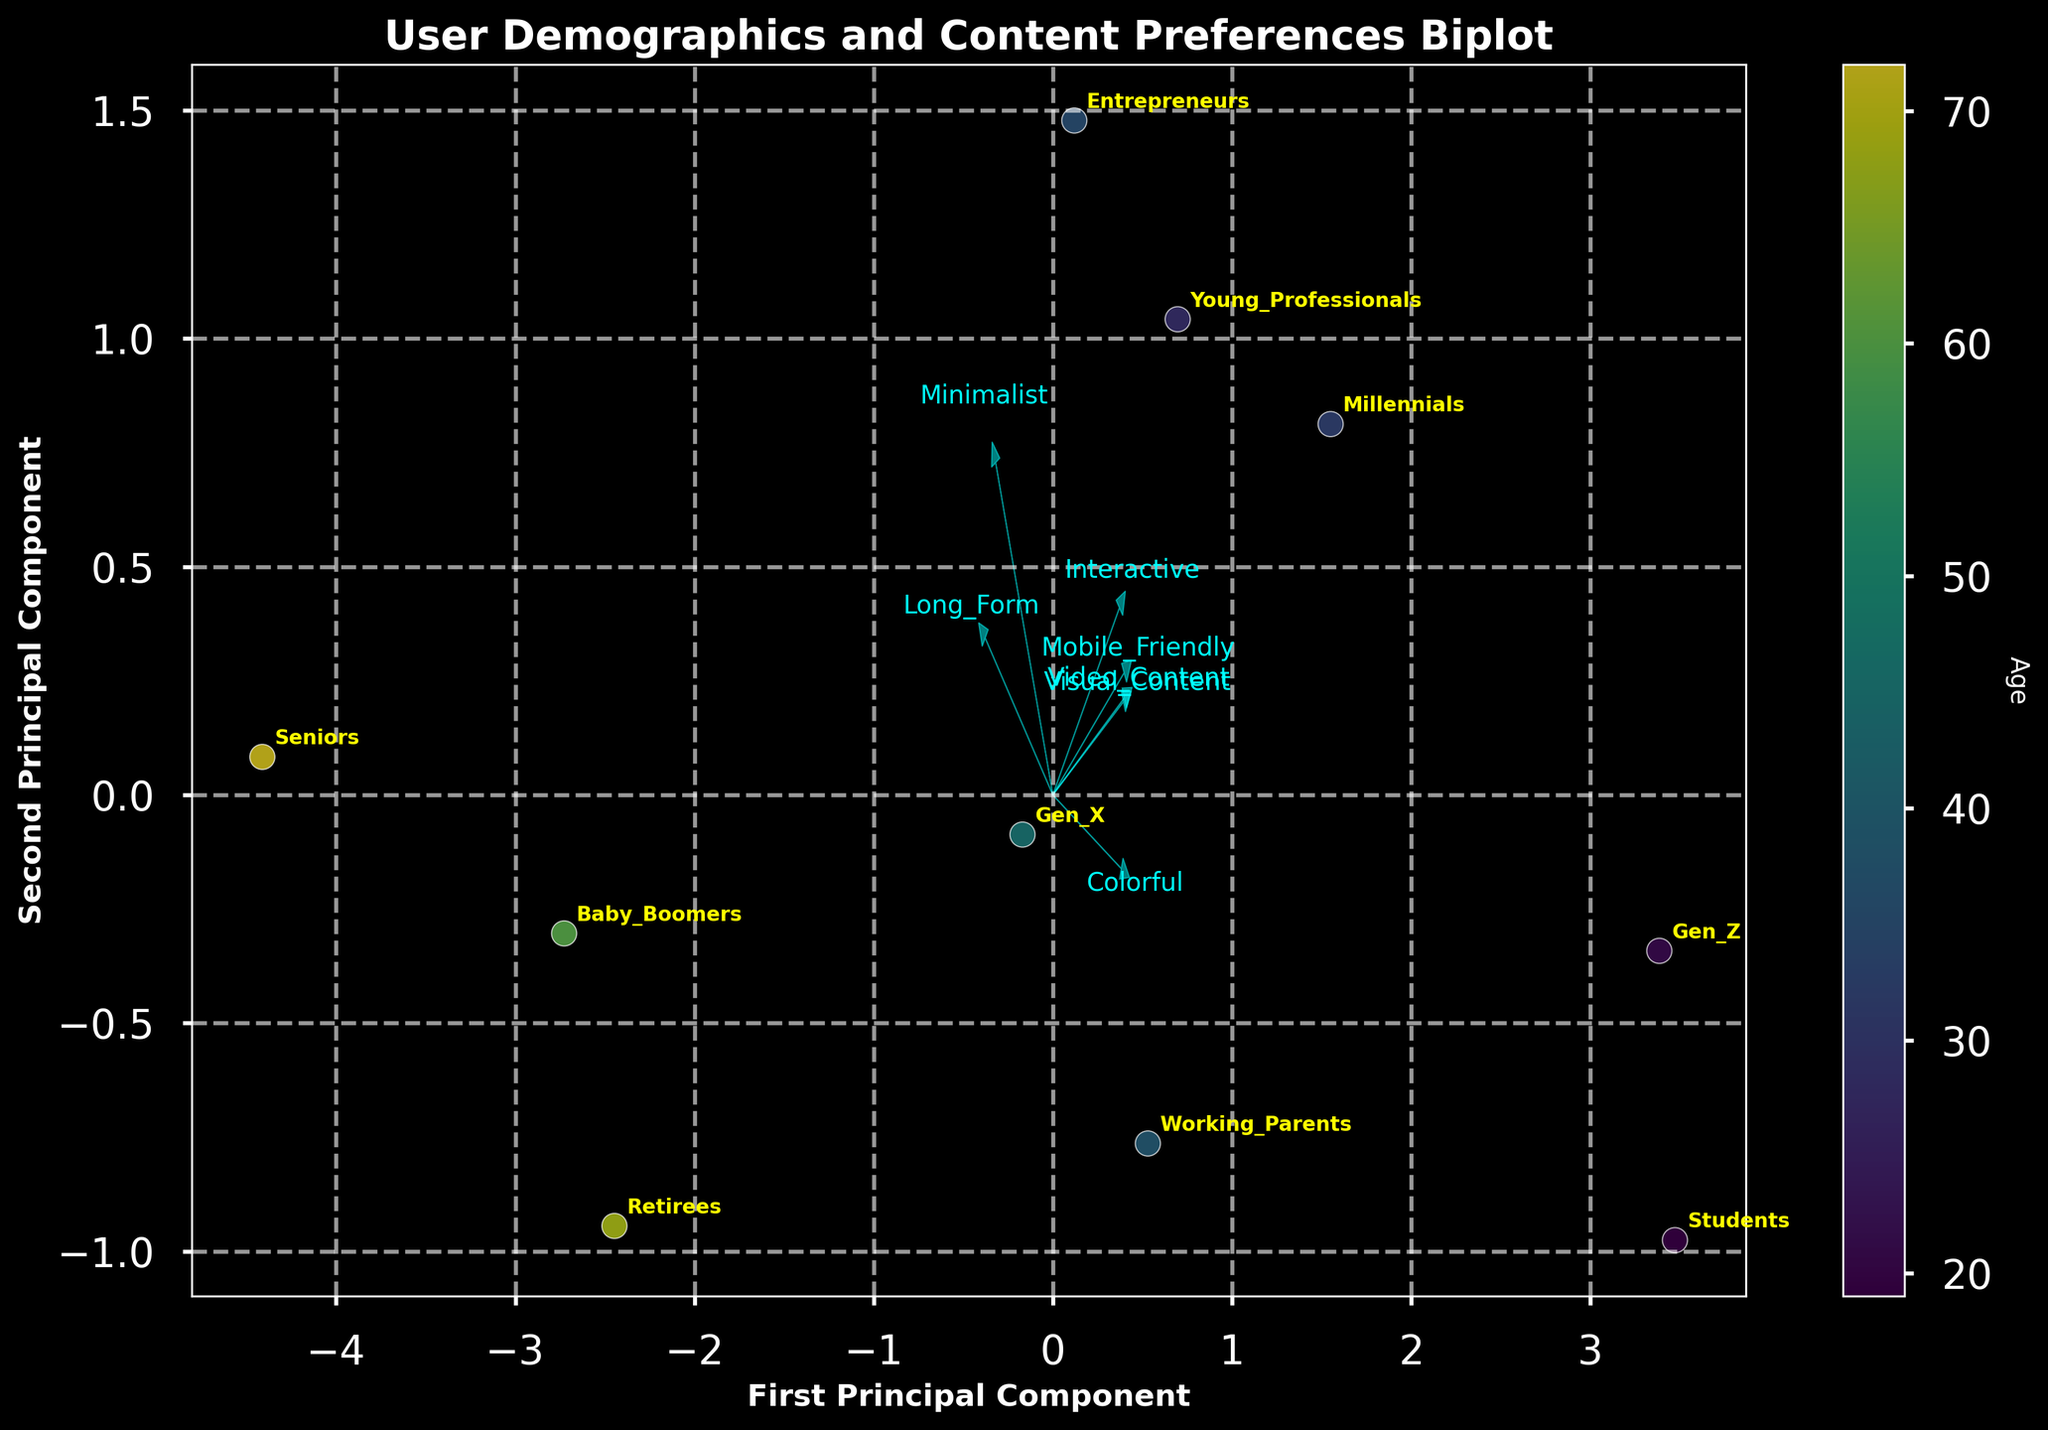What is displayed on the x-axis of the biplot? The x-axis of the biplot is labeled "First Principal Component," indicating how much of the data variance is explained by the first principal component in the PCA analysis.
Answer: First Principal Component How is age represented in the biplot? Age is represented by the color of the data points, using a color gradient going from younger to older users. A color bar on the side of the plot shows the corresponding age for each color.
Answer: Color gradient Which user group has the highest preference for "Mobile-Friendly" content? To determine this, look at which user group is positioned closest to the "Mobile-Friendly" arrow. The "Gen_Z" and "Students" groups are nearest to the "Mobile-Friendly" arrow, indicating a high preference.
Answer: Gen_Z and Students What trends can you observe regarding "Minimalist" design preferences? Observing the "Minimalist" arrow, the groups close to it (like "Seniors," "Young_Professionals," and "Entrepreneurs") show a higher preference for minimalist design styles, while those farther away show a lower preference.
Answer: Seniors, Young_Professionals, and Entrepreneurs prefer minimalist design Which groups prefer "Video_Content" the most and least? On the biplot, the groups closest to the "Video_Content" arrow have the highest preference. These include "Gen_Z" and "Students." The groups farthest from this arrow have the least preference, such as "Seniors" and "Baby_Boomers."
Answer: Most: Gen_Z and Students; Least: Seniors and Baby_Boomers How does age affect preferences for "Interactive" content? The color gradient representing age shows that younger age groups (e.g., "Gen_Z" and "Students") are closer to the "Interactive" arrow, indicating a higher preference, whereas older groups (e.g., "Seniors") are farther away.
Answer: Younger groups prefer Interactive content more Which content types have the strongest and weakest influence on the first principal component? The arrows representing the content types show their influence on the first principal component. Arrows pointing more in the direction of the x-axis have a stronger influence. "Visual_Content" and "Mobile_Friendly" have strong influences, while "Minimalist" has a weaker influence.
Answer: Strongest: Visual_Content and Mobile_Friendly; Weakest: Minimalist What can you infer about the preferences of "Working_Parents" based on their position? "Working_Parents" is positioned relatively centrally, indicating balanced preferences towards multiple content types, but not very strong preference for any specific one.
Answer: Balanced preferences How do "Gen_X" and "Millennials" compare in their content preferences? Both groups are closer to each other on the biplot, indicating similar preferences. They both lean towards "Mobile_Friendly" and "Minimalist" content but with slight differences: Millennials lean slightly more towards "Interactive" while Gen_X is closer to "Video_Content."
Answer: Similar preferences with slight differences What kind of design style do "Baby_Boomers" and "Retirees" prefer? Both "Baby_Boomers" and "Retirees" are positioned closer to the "Minimalist" arrow, indicating a preference for minimalist design styles.
Answer: Minimalist design 